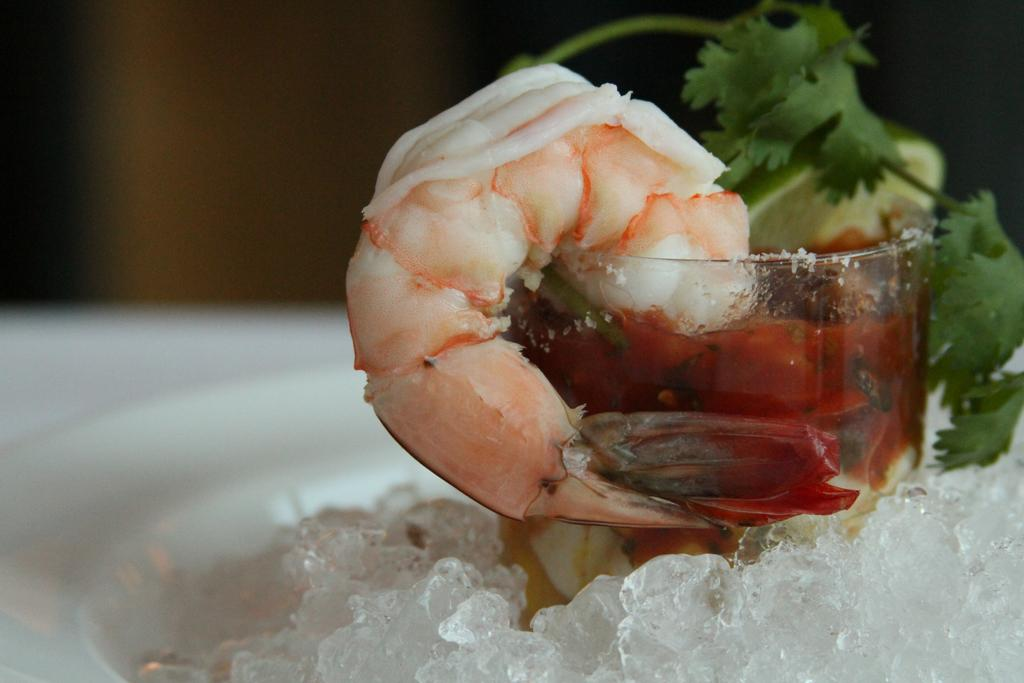What is inside the glass in the image? There is a prawn, ice, coriander leaves, and a lemon piece in the glass. Can you describe the contents of the glass in more detail? Yes, there is a prawn, ice at the bottom of the glass, coriander leaves, and a lemon piece in the glass. What type of powder is used to enhance the flavor of the prawn in the image? There is no mention of any powder being used in the image, and the flavor enhancement of the prawn is not discussed. 